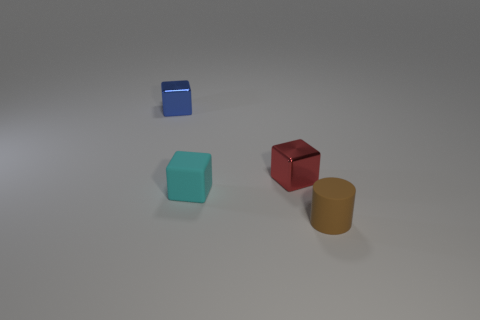Subtract all metallic cubes. How many cubes are left? 1 Add 1 tiny gray things. How many objects exist? 5 Subtract all red cubes. How many cubes are left? 2 Subtract all cylinders. How many objects are left? 3 Subtract 1 cylinders. How many cylinders are left? 0 Subtract all gray cylinders. Subtract all purple spheres. How many cylinders are left? 1 Subtract all brown matte objects. Subtract all small matte cylinders. How many objects are left? 2 Add 3 matte cylinders. How many matte cylinders are left? 4 Add 4 large green cylinders. How many large green cylinders exist? 4 Subtract 0 brown balls. How many objects are left? 4 